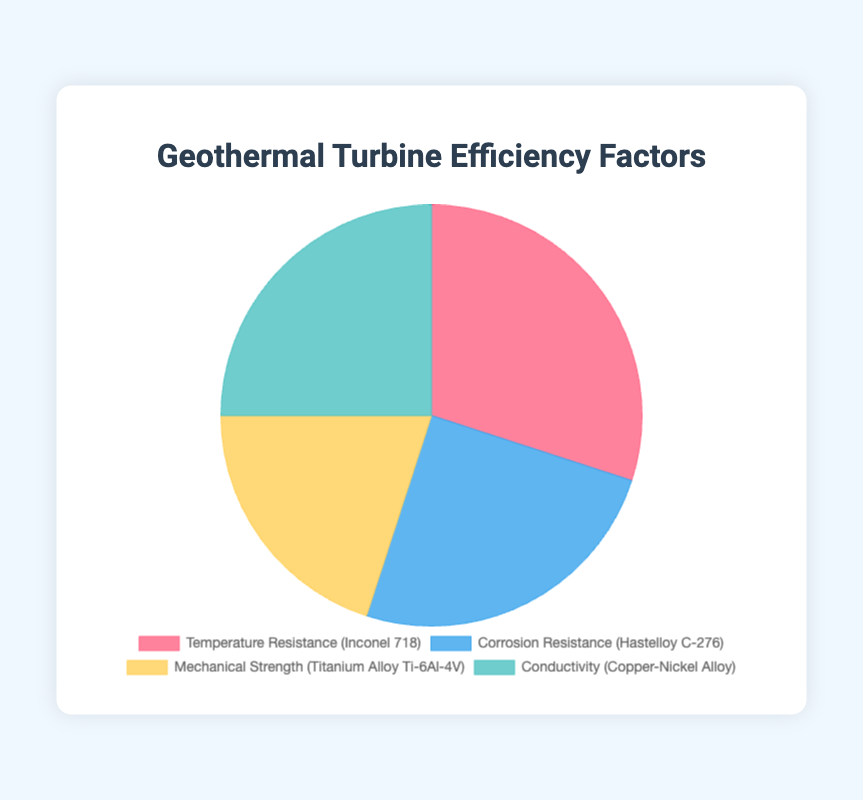What is the most significant factor contributing to Geothermal Turbine Efficiency? The chart shows the efficiency percentages for each factor. The highest percentage is for Temperature Resistance, with 30%.
Answer: Temperature Resistance Which factor has the least contribution to Geothermal Turbine Efficiency? By examining the pie chart, Mechanical Strength has the lowest percentage contribution of 20%.
Answer: Mechanical Strength How much greater is the contribution of Temperature Resistance compared to Mechanical Strength? Temperature Resistance contributes 30% and Mechanical Strength contributes 20%. The difference is 30% - 20% = 10%.
Answer: 10% What are the contributing factors that have equal efficiency percentages? Both Corrosion Resistance and Conductivity have efficiency percentages of 25%, so they are equal.
Answer: Corrosion Resistance and Conductivity What is the combined contribution percentage of Corrosion Resistance and Conductivity? Corrosion Resistance contributes 25% and Conductivity contributes 25%. The combined percentage is 25% + 25% = 50%.
Answer: 50% Rank the factors from highest to lowest in terms of their contribution to Geothermal Turbine Efficiency. The pie chart reveals the following order from highest to lowest: Temperature Resistance (30%), Corrosion Resistance (25%) and Conductivity (25%), Mechanical Strength (20%).
Answer: Temperature Resistance, Corrosion Resistance and Conductivity (tie), Mechanical Strength What is the total percentage contribution of factors related to resistance (Temperature and Corrosion)? Temperature Resistance contributes 30% and Corrosion Resistance contributes 25%. The combined contribution is 30% + 25% = 55%.
Answer: 55% Which color represents the factor with the highest efficiency percentage in the chart? The color representing Temperature Resistance is red. Since this factor has the highest percentage of 30%, the red color is associated with it.
Answer: Red Is there any factor directly related to electric conduction? If yes, what percentage does it contribute? Conductivity is directly related to electric conduction, and its efficiency percentage is 25%.
Answer: 25% If we combine the contributions of mechanical and electrical properties (Mechanical Strength and Conductivity), how much is the total efficiency percentage? Mechanical Strength contributes 20% and Conductivity contributes 25%. The combined efficiency percentage is 20% + 25% = 45%.
Answer: 45% 